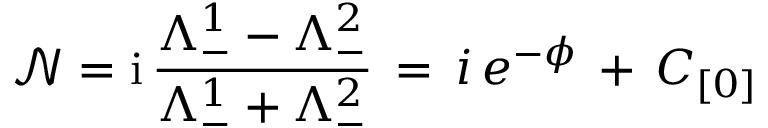<formula> <loc_0><loc_0><loc_500><loc_500>\mathcal { N } = i \, \frac { \Lambda _ { - } ^ { 1 } - \Lambda _ { - } ^ { 2 } } { \Lambda _ { - } ^ { 1 } + \Lambda _ { - } ^ { 2 } } \, = \, i \, e ^ { - \phi } \, + \, C _ { [ 0 ] }</formula> 